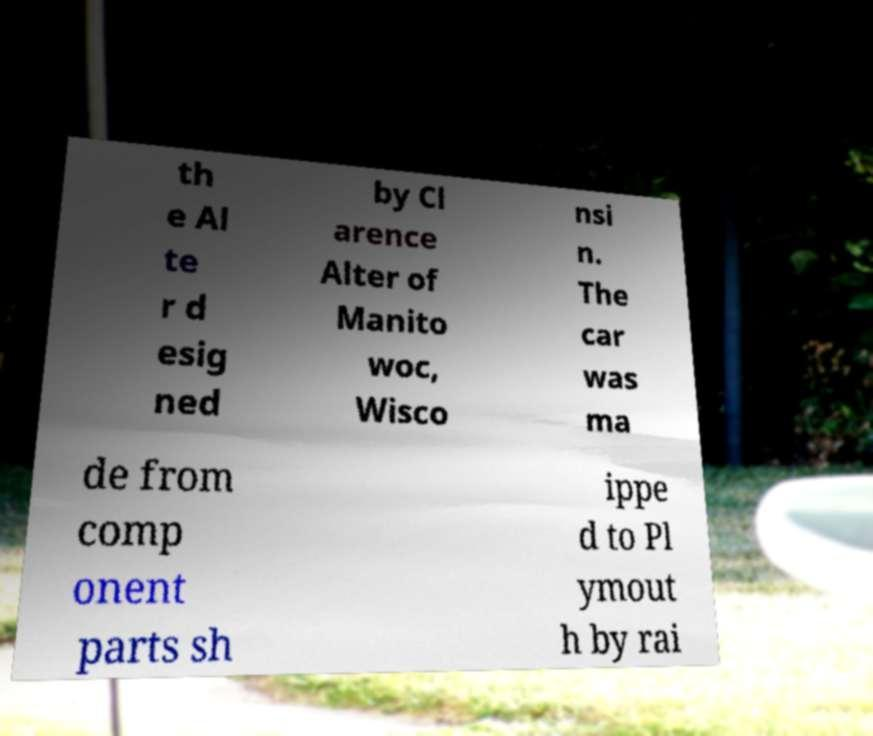Could you assist in decoding the text presented in this image and type it out clearly? th e Al te r d esig ned by Cl arence Alter of Manito woc, Wisco nsi n. The car was ma de from comp onent parts sh ippe d to Pl ymout h by rai 